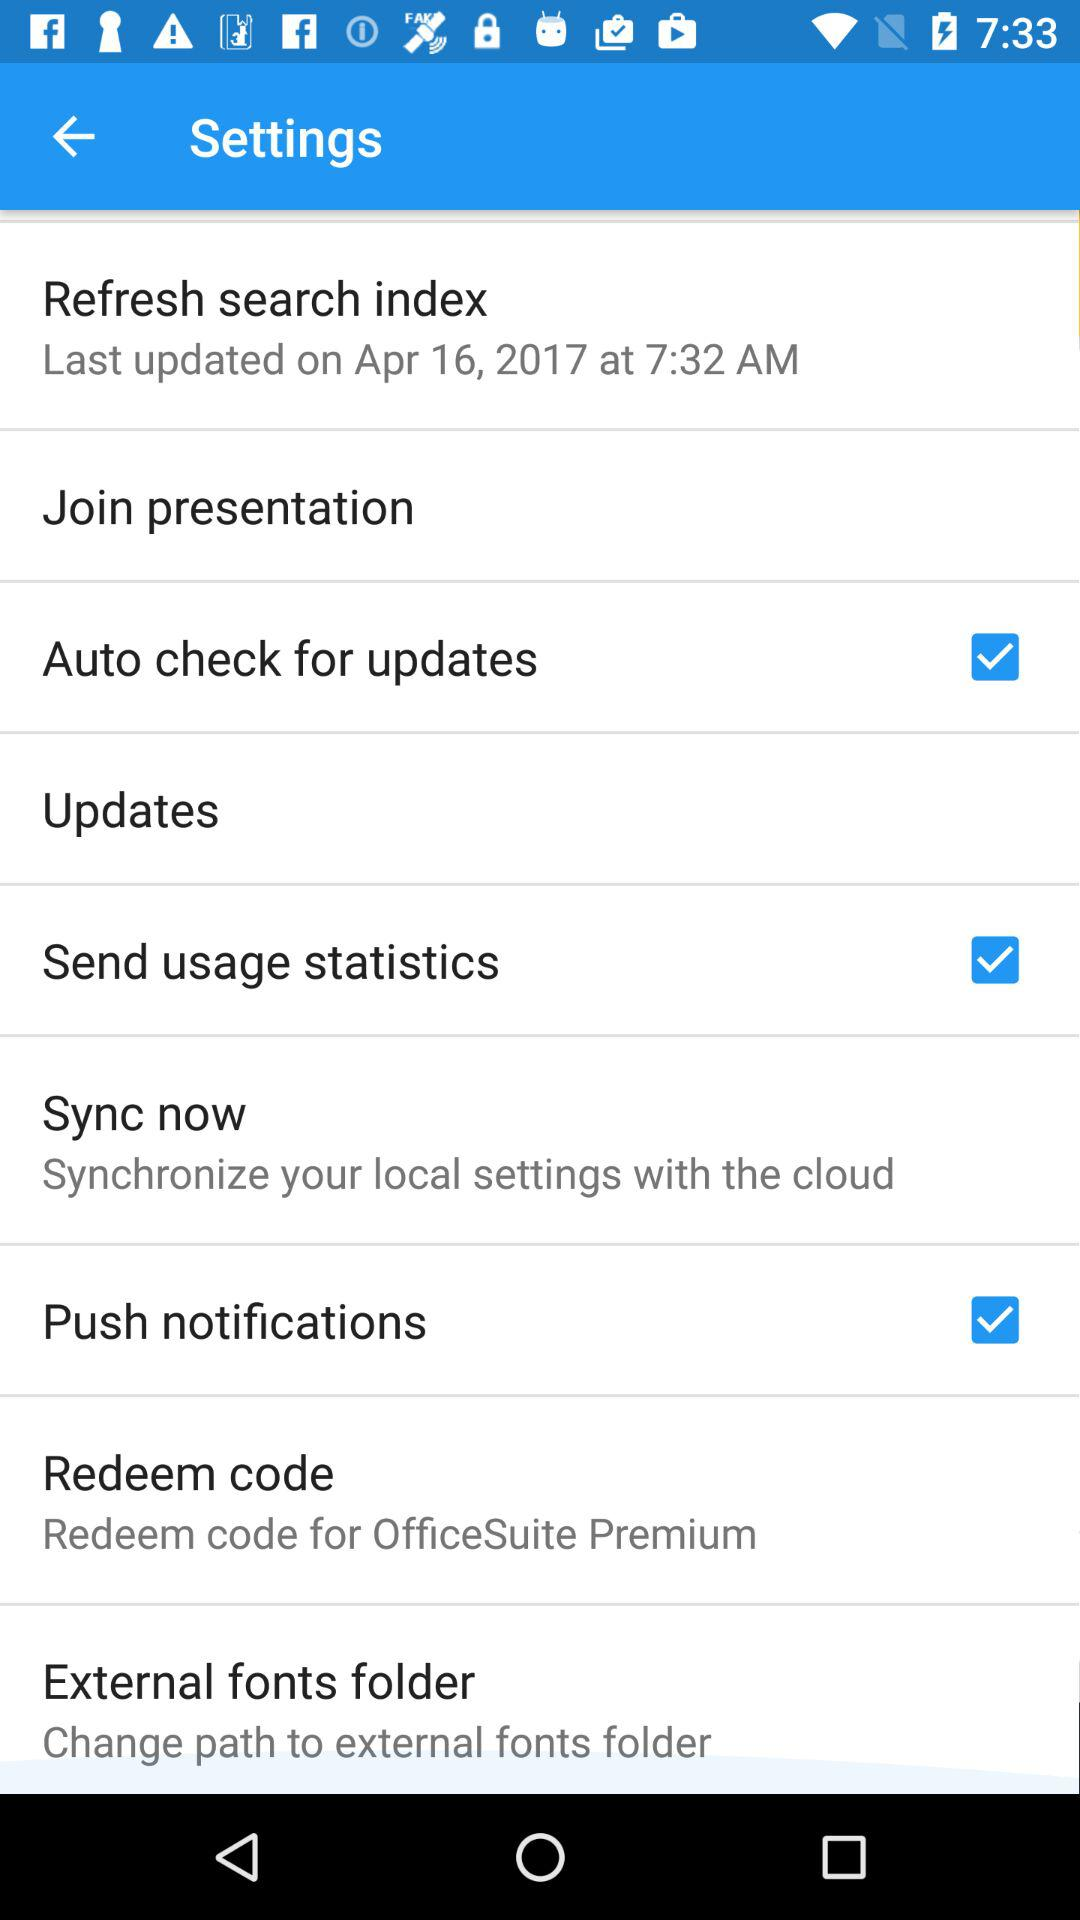Which option is selected for redeem code?
When the provided information is insufficient, respond with <no answer>. <no answer> 